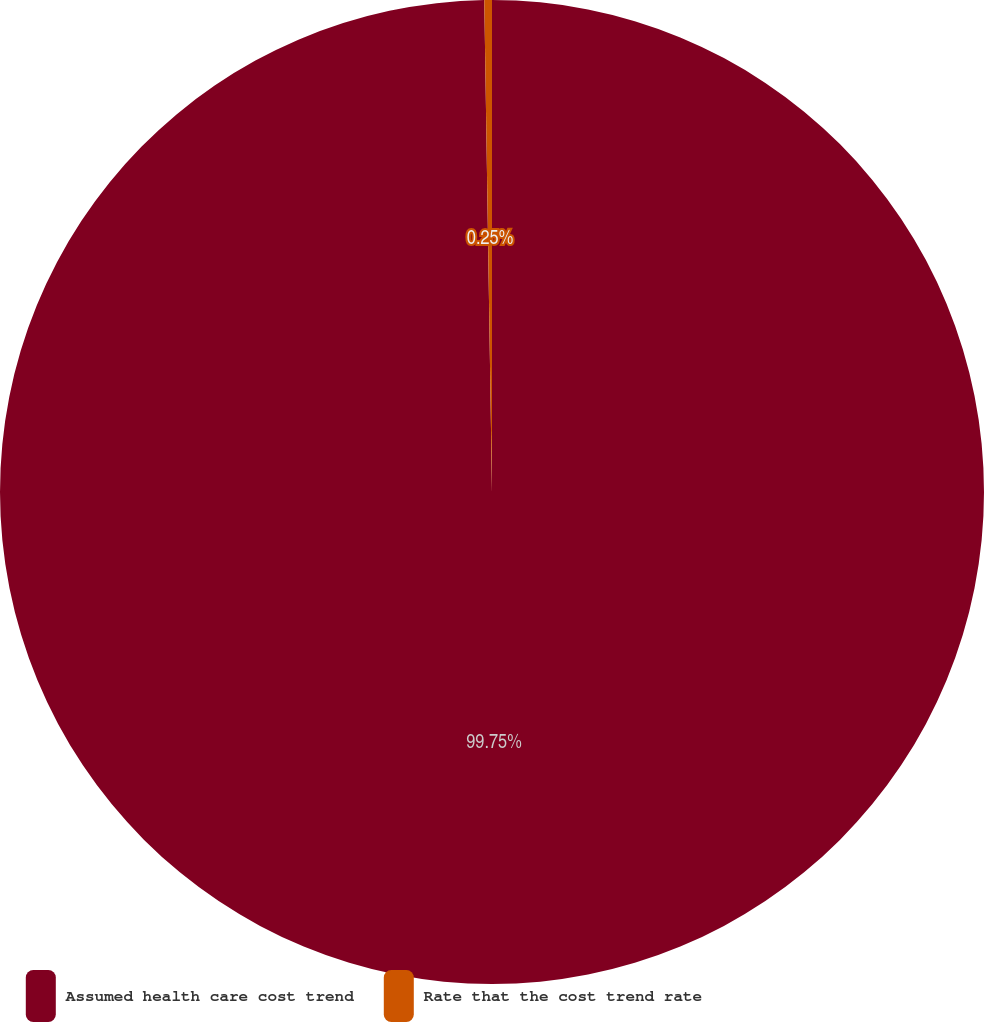Convert chart to OTSL. <chart><loc_0><loc_0><loc_500><loc_500><pie_chart><fcel>Assumed health care cost trend<fcel>Rate that the cost trend rate<nl><fcel>99.75%<fcel>0.25%<nl></chart> 